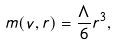Convert formula to latex. <formula><loc_0><loc_0><loc_500><loc_500>m ( v , r ) = \frac { \Lambda } { 6 } r ^ { 3 } ,</formula> 